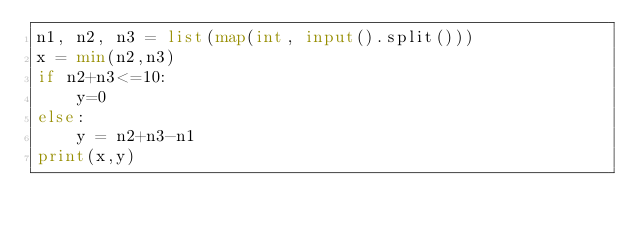Convert code to text. <code><loc_0><loc_0><loc_500><loc_500><_Python_>n1, n2, n3 = list(map(int, input().split()))
x = min(n2,n3)
if n2+n3<=10:
    y=0
else:
    y = n2+n3-n1
print(x,y)</code> 